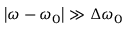Convert formula to latex. <formula><loc_0><loc_0><loc_500><loc_500>\left | \omega - \omega _ { 0 } \right | \gg \Delta \omega _ { 0 }</formula> 